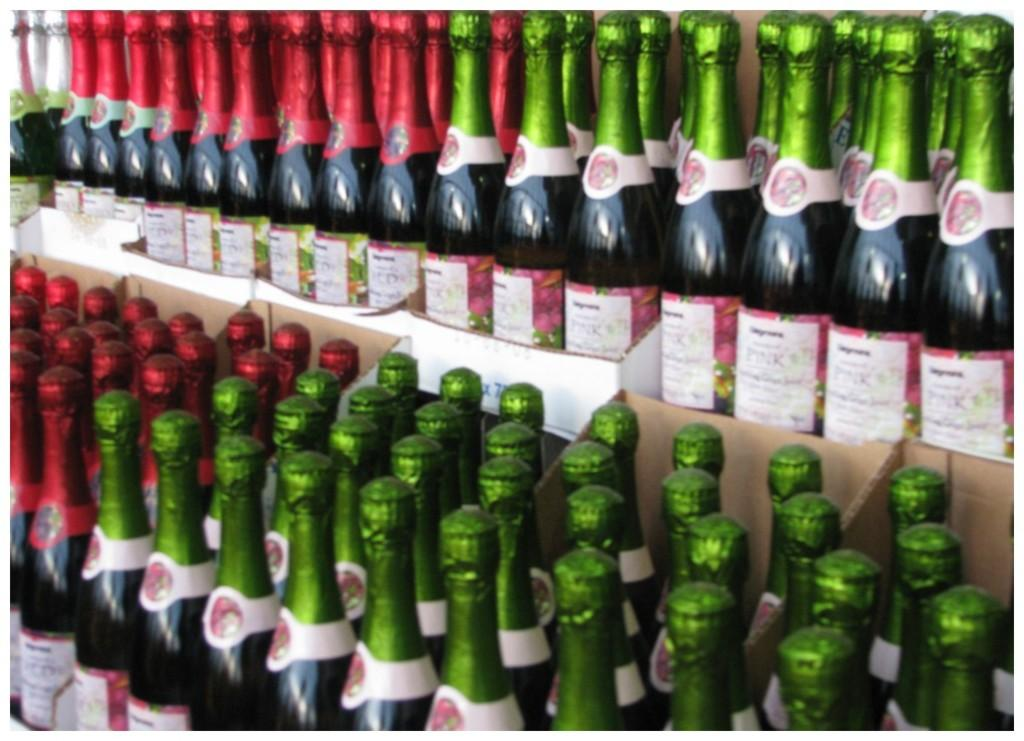<image>
Share a concise interpretation of the image provided. Bottles of Seagrams sparkling drink are on a shelf. 